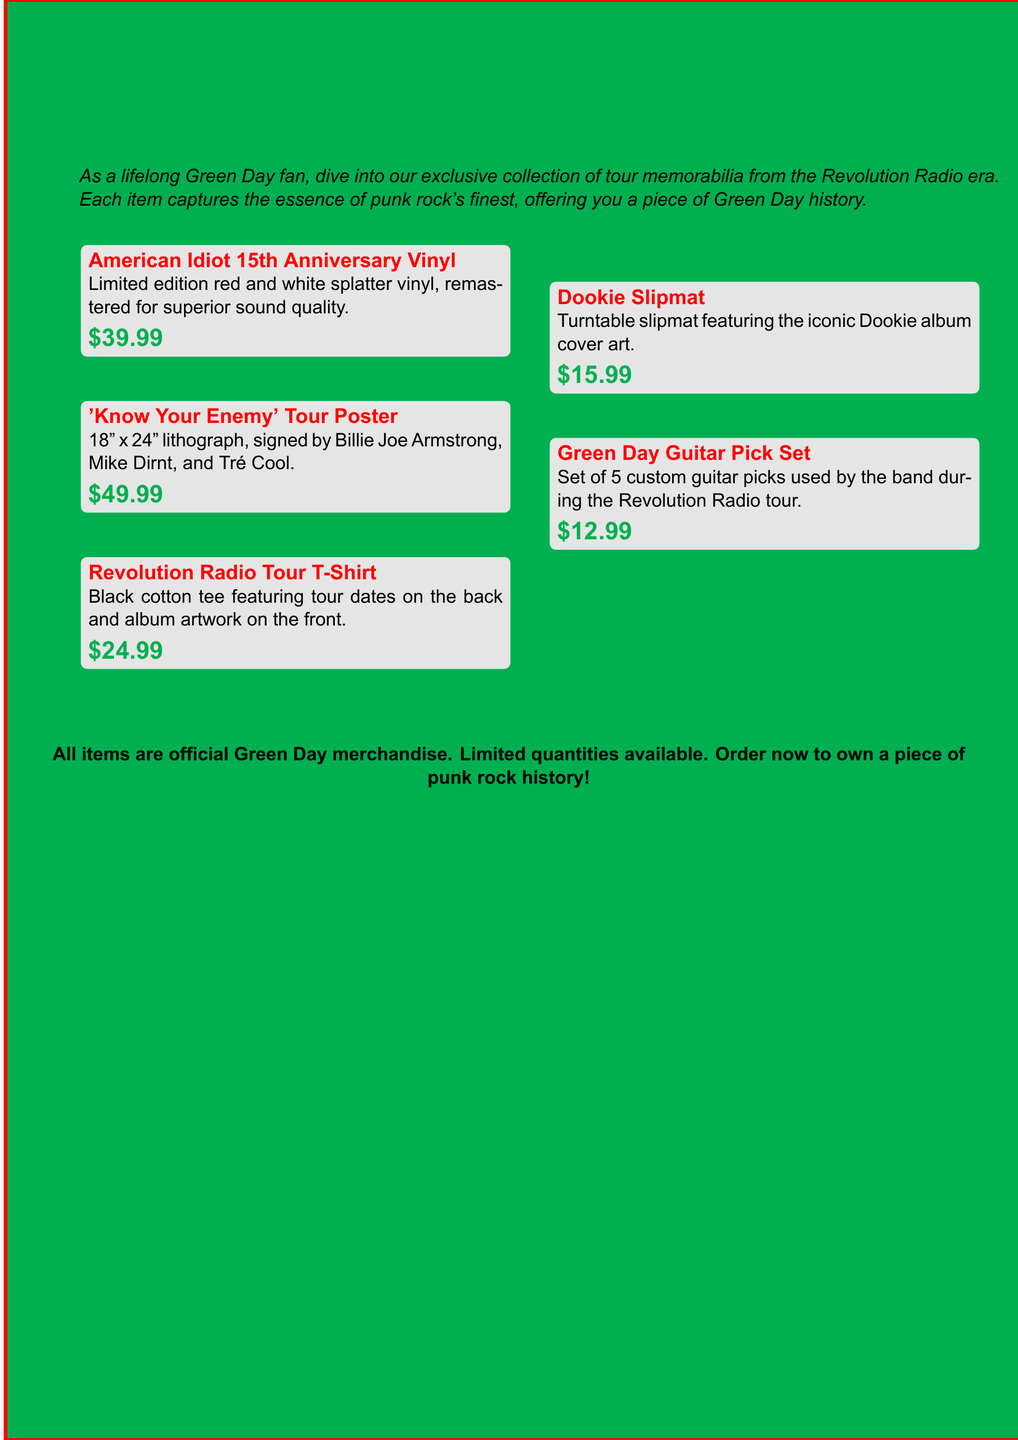What is the price of the 'Know Your Enemy' tour poster? The price of the 'Know Your Enemy' tour poster can be found in the merchandise catalog, which lists it as $49.99.
Answer: $49.99 How many items are there in the catalog? The catalog lists five different items, so the total number can be identified directly from the document.
Answer: Five What color is the Revolution Radio tour t-shirt? The catalog specifies that the tour t-shirt is a black cotton tee, making it easy to retrieve this detail.
Answer: Black Who signed the 'Know Your Enemy' tour poster? The document mentions that the poster is signed by Billie Joe Armstrong, Mike Dirnt, and Tré Cool, providing specific names.
Answer: Billie Joe Armstrong, Mike Dirnt, and Tré Cool What type of vinyl record is being sold? The catalog describes the vinyl as a limited edition red and white splatter vinyl, highlighting its unique characteristics.
Answer: Red and white splatter vinyl What is the featured artwork on the Dookie slipmat? The slipmat features the iconic Dookie album cover art, which is clearly stated in the item description.
Answer: Dookie album cover art How much does the Green Day guitar pick set cost? The cost of the Green Day guitar pick set is mentioned in the document, allowing for easy retrieval of this information.
Answer: $12.99 What promotional statement follows the item listings? The document has a promotional statement urging customers to order quickly because all items are official merchandise with limited quantities.
Answer: Limited quantities available. Order now to own a piece of punk rock history! What is the main theme of the memorabilia collection? The introduction of the document emphasizes that the collection is focused on the Revolution Radio era of Green Day, making this the central theme.
Answer: Revolution Radio era 